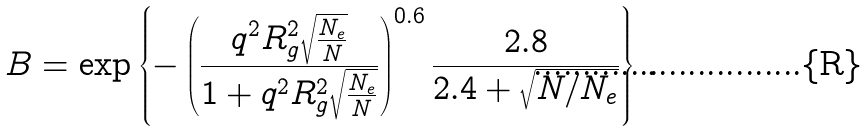Convert formula to latex. <formula><loc_0><loc_0><loc_500><loc_500>B = \exp \left \{ - \left ( \frac { q ^ { 2 } R _ { g } ^ { 2 } \sqrt { \frac { N _ { e } } { N } } } { 1 + q ^ { 2 } R _ { g } ^ { 2 } \sqrt { \frac { N _ { e } } { N } } } \right ) ^ { 0 . 6 } \frac { 2 . 8 } { 2 . 4 + \sqrt { N / N _ { e } } } \right \} \, .</formula> 